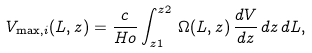<formula> <loc_0><loc_0><loc_500><loc_500>V _ { \max , i } ( L , z ) = \frac { c } { H o } \int _ { z 1 } ^ { z 2 } \, \Omega ( L , z ) \, \frac { d V } { d z } \, d z \, d L ,</formula> 